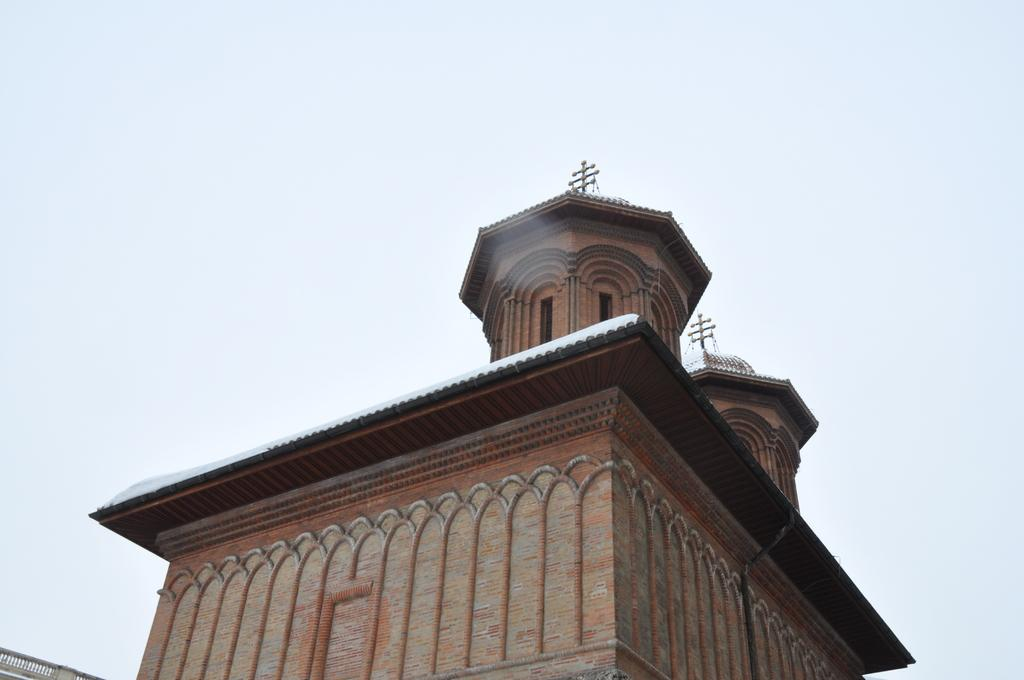What is the main subject in the foreground of the picture? There is a building in the foreground of the picture. What can be seen in the background of the image? The sky is visible at the top of the image. How many trucks are parked near the building in the image? There is no information about trucks in the image, so we cannot determine how many are present. 